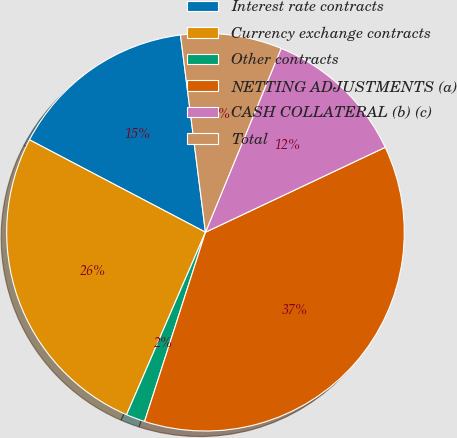Convert chart to OTSL. <chart><loc_0><loc_0><loc_500><loc_500><pie_chart><fcel>Interest rate contracts<fcel>Currency exchange contracts<fcel>Other contracts<fcel>NETTING ADJUSTMENTS (a)<fcel>CASH COLLATERAL (b) (c)<fcel>Total<nl><fcel>15.3%<fcel>26.2%<fcel>1.54%<fcel>36.98%<fcel>11.76%<fcel>8.22%<nl></chart> 